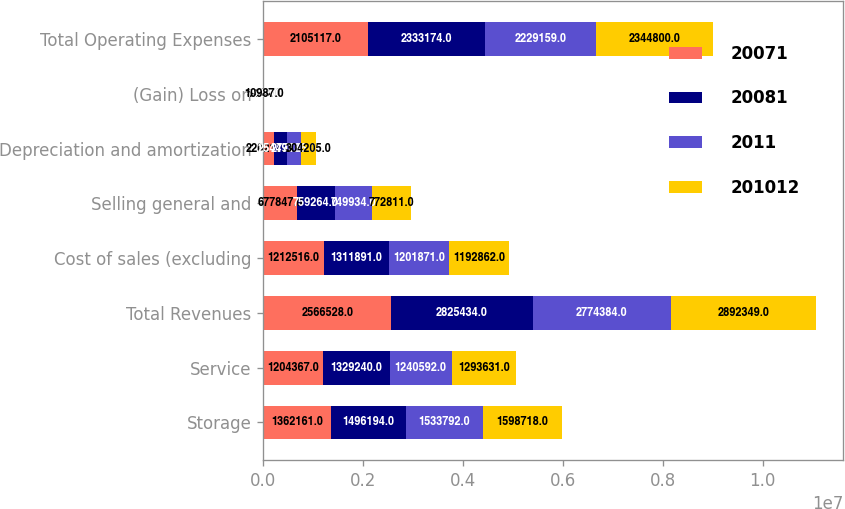Convert chart. <chart><loc_0><loc_0><loc_500><loc_500><stacked_bar_chart><ecel><fcel>Storage<fcel>Service<fcel>Total Revenues<fcel>Cost of sales (excluding<fcel>Selling general and<fcel>Depreciation and amortization<fcel>(Gain) Loss on<fcel>Total Operating Expenses<nl><fcel>20071<fcel>1.36216e+06<fcel>1.20437e+06<fcel>2.56653e+06<fcel>1.21252e+06<fcel>677847<fcel>220217<fcel>5463<fcel>2.10512e+06<nl><fcel>20081<fcel>1.49619e+06<fcel>1.32924e+06<fcel>2.82543e+06<fcel>1.31189e+06<fcel>759264<fcel>254497<fcel>7522<fcel>2.33317e+06<nl><fcel>2011<fcel>1.53379e+06<fcel>1.24059e+06<fcel>2.77438e+06<fcel>1.20187e+06<fcel>749934<fcel>277186<fcel>168<fcel>2.22916e+06<nl><fcel>201012<fcel>1.59872e+06<fcel>1.29363e+06<fcel>2.89235e+06<fcel>1.19286e+06<fcel>772811<fcel>304205<fcel>10987<fcel>2.3448e+06<nl></chart> 